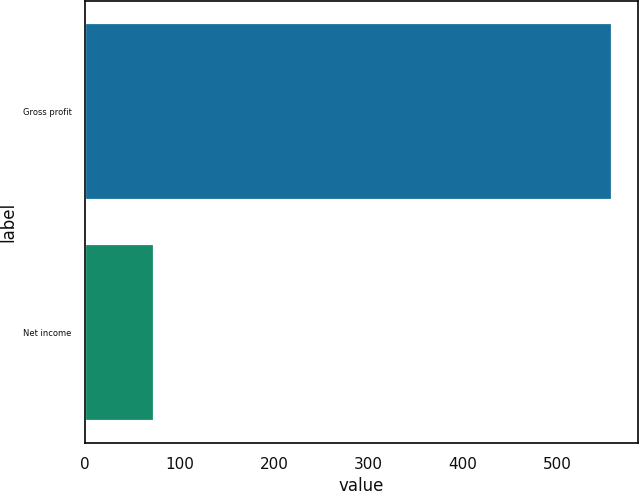<chart> <loc_0><loc_0><loc_500><loc_500><bar_chart><fcel>Gross profit<fcel>Net income<nl><fcel>558.1<fcel>73.2<nl></chart> 